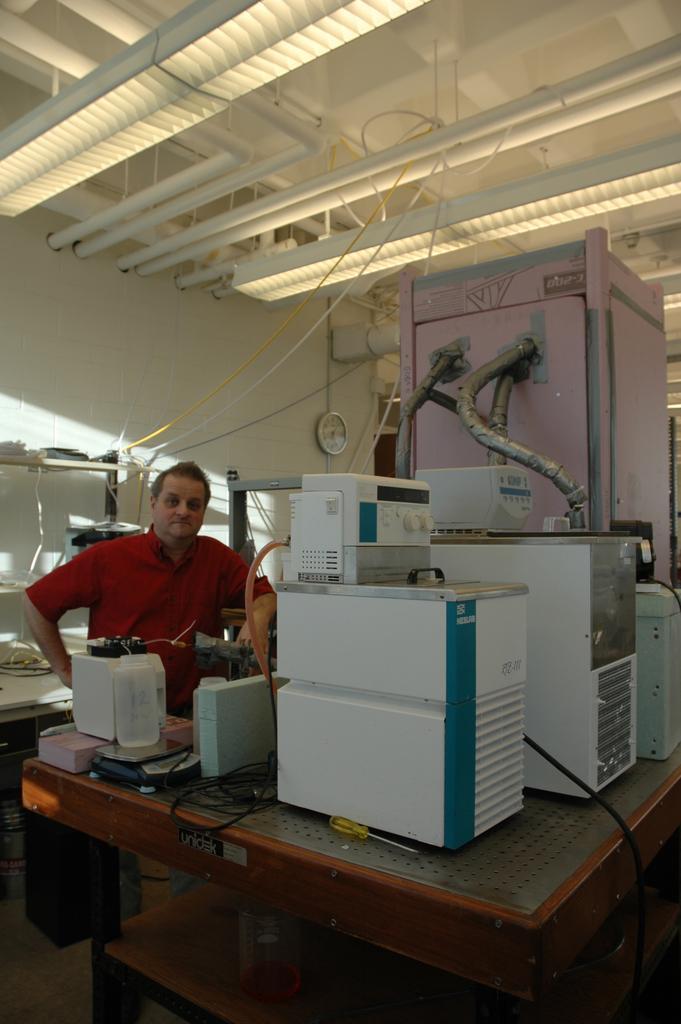How would you summarize this image in a sentence or two? In this image I can see a man is standing and wearing a red color of shirt. In the background on this wall I can see a clock. On this table I can see few machines. 